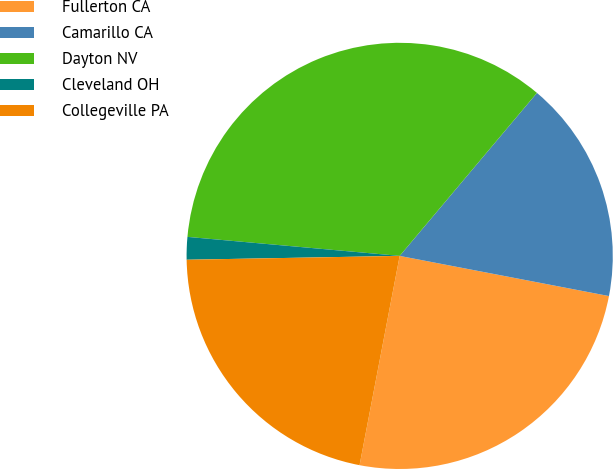<chart> <loc_0><loc_0><loc_500><loc_500><pie_chart><fcel>Fullerton CA<fcel>Camarillo CA<fcel>Dayton NV<fcel>Cleveland OH<fcel>Collegeville PA<nl><fcel>25.0%<fcel>16.88%<fcel>34.72%<fcel>1.71%<fcel>21.7%<nl></chart> 